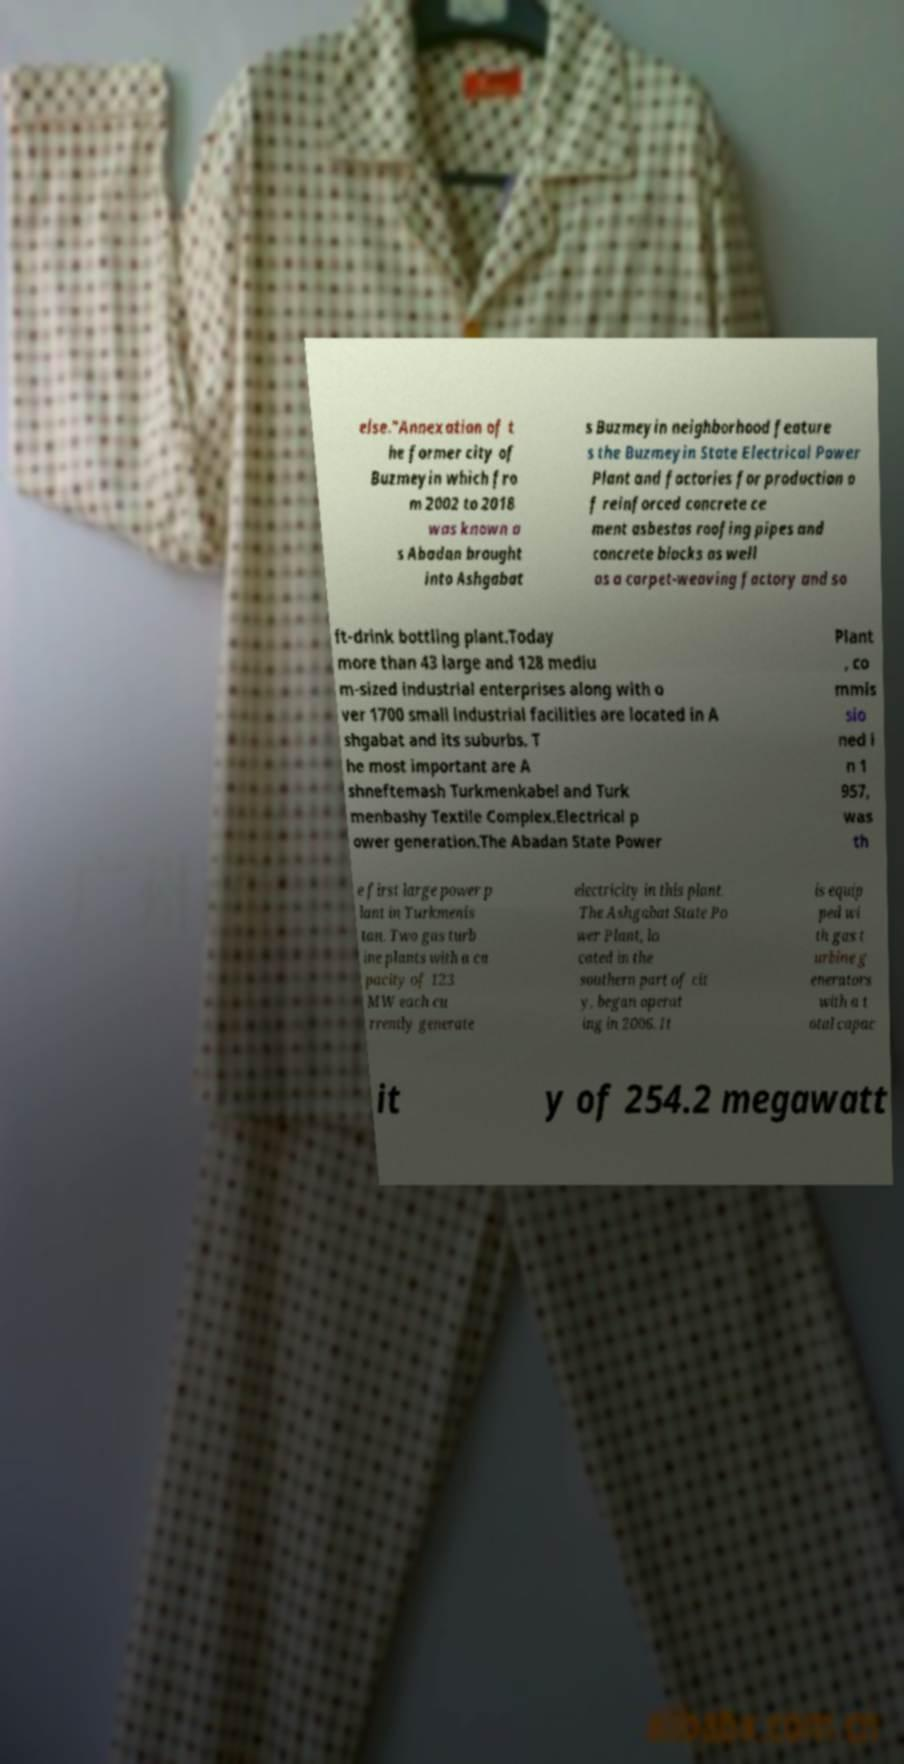What messages or text are displayed in this image? I need them in a readable, typed format. else."Annexation of t he former city of Buzmeyin which fro m 2002 to 2018 was known a s Abadan brought into Ashgabat s Buzmeyin neighborhood feature s the Buzmeyin State Electrical Power Plant and factories for production o f reinforced concrete ce ment asbestos roofing pipes and concrete blocks as well as a carpet-weaving factory and so ft-drink bottling plant.Today more than 43 large and 128 mediu m-sized industrial enterprises along with o ver 1700 small industrial facilities are located in A shgabat and its suburbs. T he most important are A shneftemash Turkmenkabel and Turk menbashy Textile Complex.Electrical p ower generation.The Abadan State Power Plant , co mmis sio ned i n 1 957, was th e first large power p lant in Turkmenis tan. Two gas turb ine plants with a ca pacity of 123 MW each cu rrently generate electricity in this plant. The Ashgabat State Po wer Plant, lo cated in the southern part of cit y, began operat ing in 2006. It is equip ped wi th gas t urbine g enerators with a t otal capac it y of 254.2 megawatt 